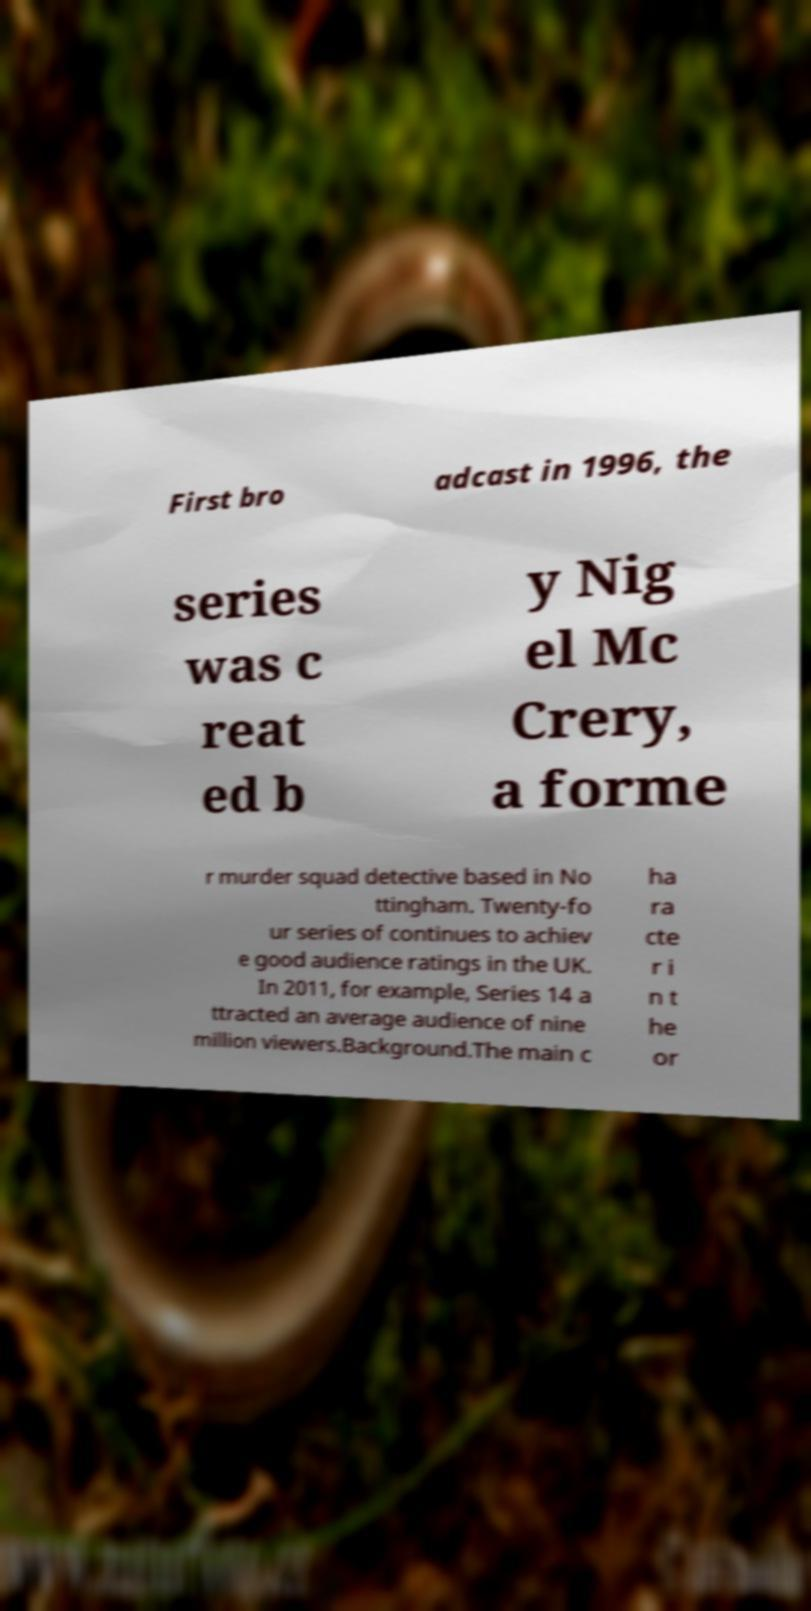There's text embedded in this image that I need extracted. Can you transcribe it verbatim? First bro adcast in 1996, the series was c reat ed b y Nig el Mc Crery, a forme r murder squad detective based in No ttingham. Twenty-fo ur series of continues to achiev e good audience ratings in the UK. In 2011, for example, Series 14 a ttracted an average audience of nine million viewers.Background.The main c ha ra cte r i n t he or 